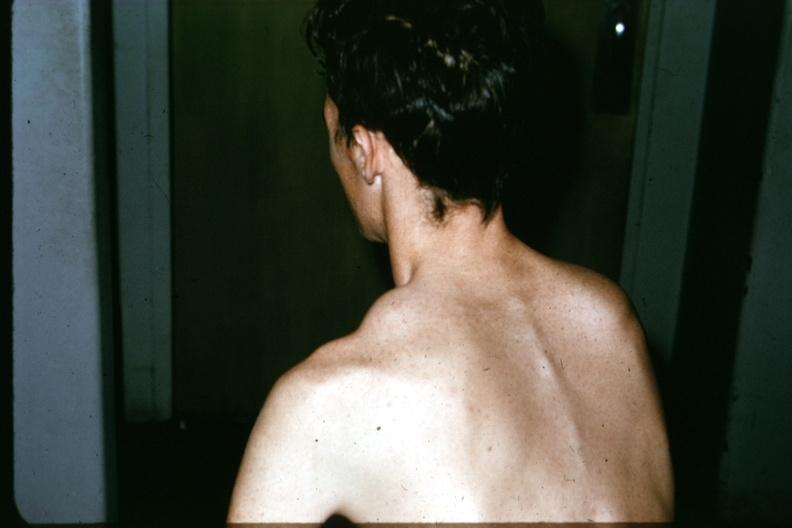what is present?
Answer the question using a single word or phrase. Joints 